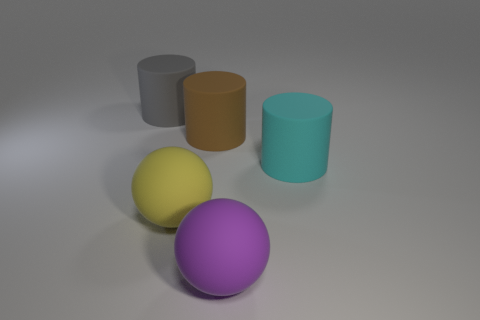What number of large brown rubber things are there?
Ensure brevity in your answer.  1. How many balls are either large purple rubber things or cyan matte things?
Offer a very short reply. 1. There is a matte ball that is the same size as the yellow matte object; what is its color?
Keep it short and to the point. Purple. How many big objects are behind the cyan cylinder and in front of the cyan cylinder?
Make the answer very short. 0. What number of things are either purple matte spheres or large brown metallic things?
Provide a succinct answer. 1. What number of other objects are there of the same size as the brown rubber thing?
Offer a terse response. 4. What number of things are large cylinders right of the large purple object or rubber things that are on the left side of the purple matte object?
Provide a short and direct response. 4. Does the big yellow ball have the same material as the cylinder that is on the right side of the purple rubber sphere?
Keep it short and to the point. Yes. What number of other things are the same shape as the big brown thing?
Make the answer very short. 2. What is the ball that is to the right of the large matte sphere that is left of the large matte sphere that is to the right of the large yellow ball made of?
Make the answer very short. Rubber. 